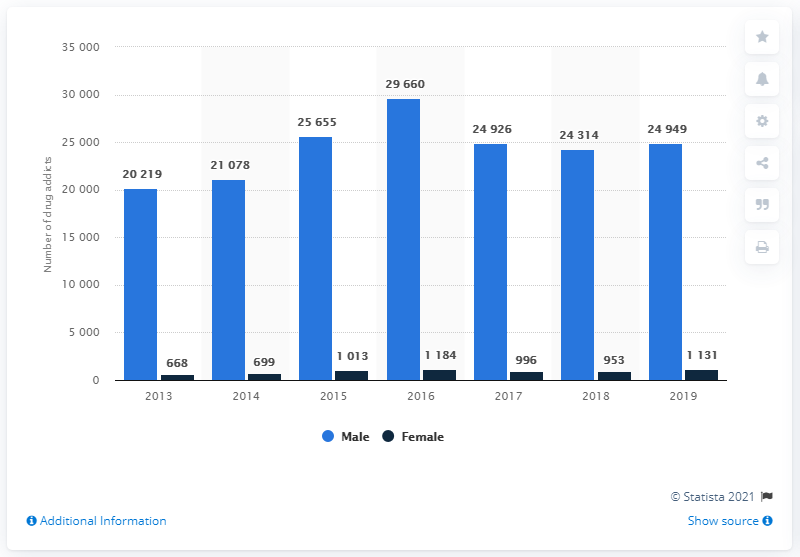Give some essential details in this illustration. In 2019, there were 24,949 males in Malaysia who had at least one drug offense. 